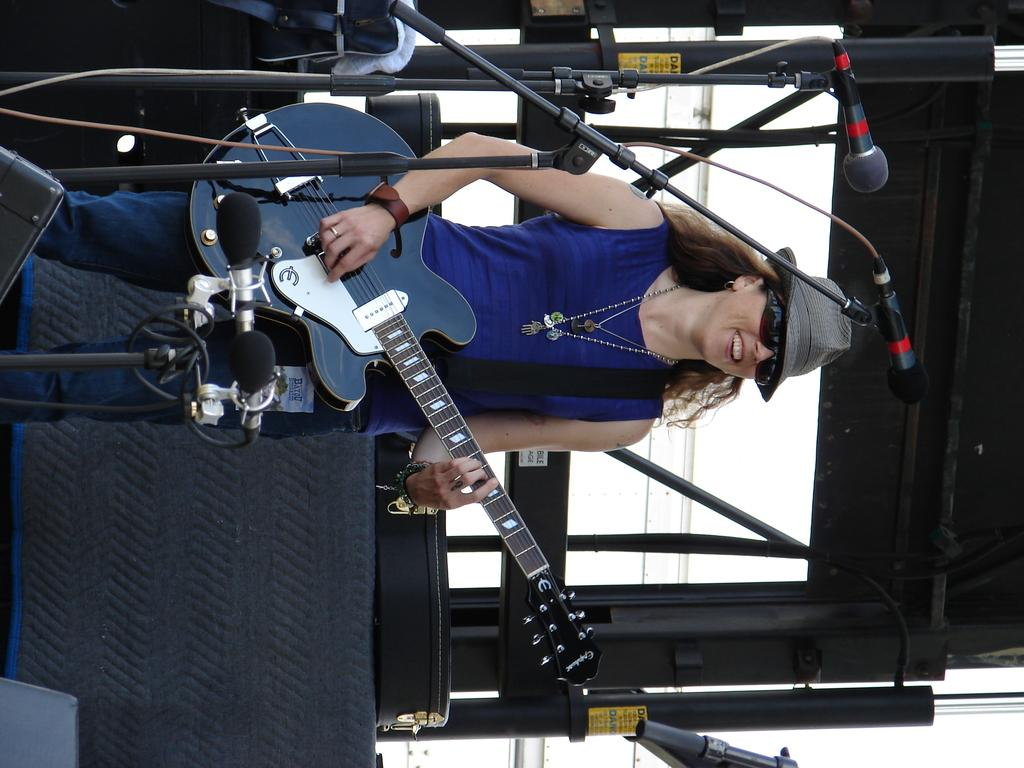Who is the main subject in the image? There is a woman in the image. What is the woman doing in the image? The woman is standing in the image. What object is the woman holding in her hand? The woman is holding a guitar in her hand. What type of connection can be seen between the woman and the cemetery in the image? There is no cemetery present in the image, so no connection can be observed between the woman and a cemetery. 